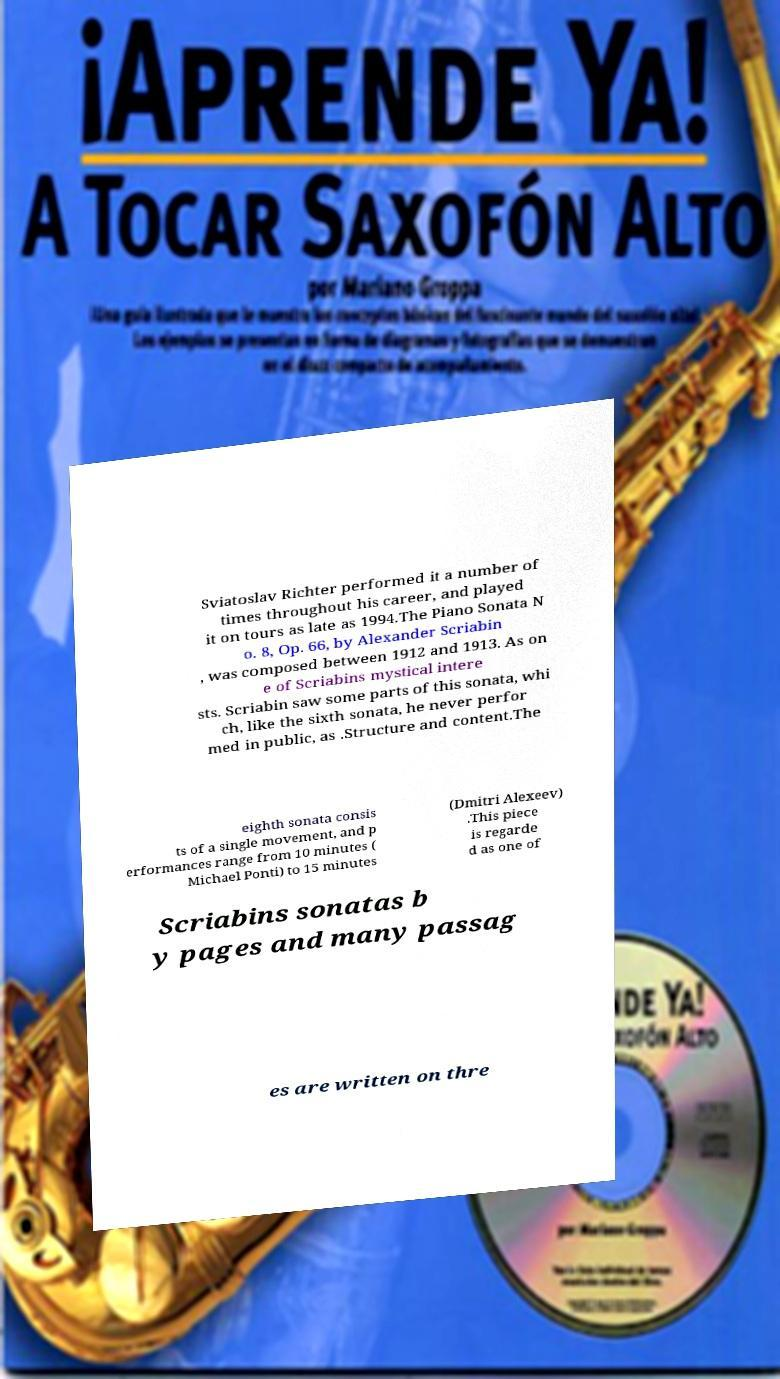For documentation purposes, I need the text within this image transcribed. Could you provide that? Sviatoslav Richter performed it a number of times throughout his career, and played it on tours as late as 1994.The Piano Sonata N o. 8, Op. 66, by Alexander Scriabin , was composed between 1912 and 1913. As on e of Scriabins mystical intere sts. Scriabin saw some parts of this sonata, whi ch, like the sixth sonata, he never perfor med in public, as .Structure and content.The eighth sonata consis ts of a single movement, and p erformances range from 10 minutes ( Michael Ponti) to 15 minutes (Dmitri Alexeev) .This piece is regarde d as one of Scriabins sonatas b y pages and many passag es are written on thre 